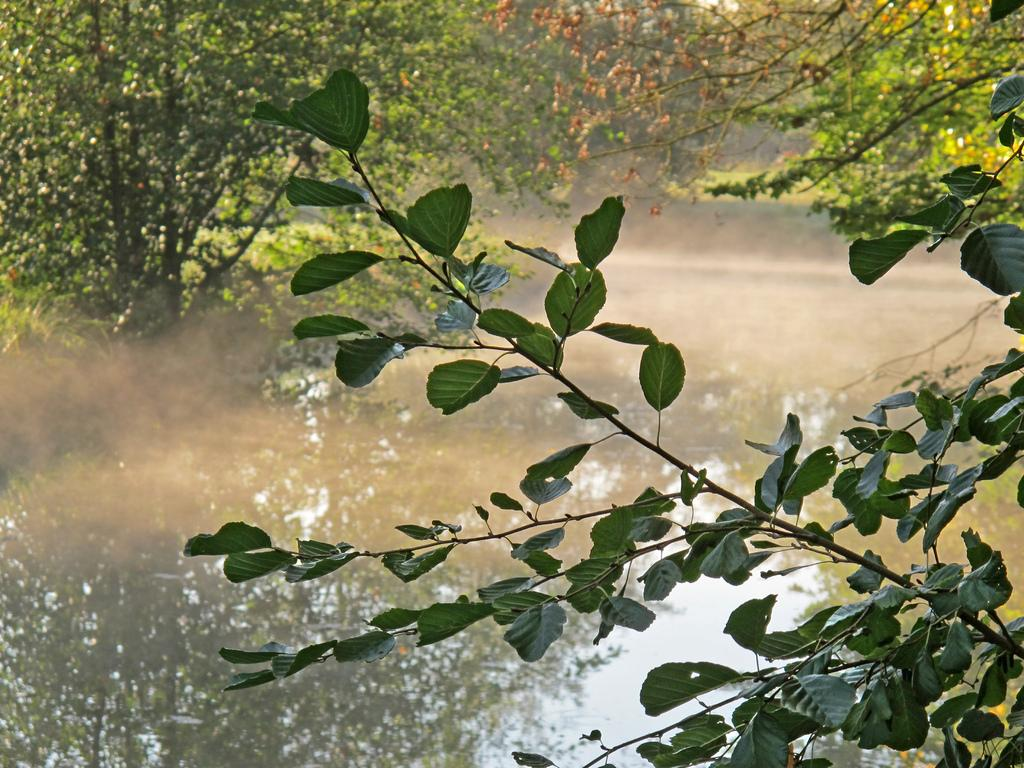What is visible in the image? There is water visible in the image. What can be seen on the right side of the image? There are leaves on the right side of the image. What is visible in the background of the image? There are many trees in the background of the image. Where is the birth certificate located in the image? There is no birth certificate present in the image. What type of fold can be seen in the image? There is no fold visible in the image. 